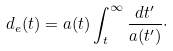<formula> <loc_0><loc_0><loc_500><loc_500>d _ { e } ( t ) = a ( t ) \int _ { t } ^ { \infty } \frac { d t ^ { \prime } } { a ( t ^ { \prime } ) } \cdot</formula> 